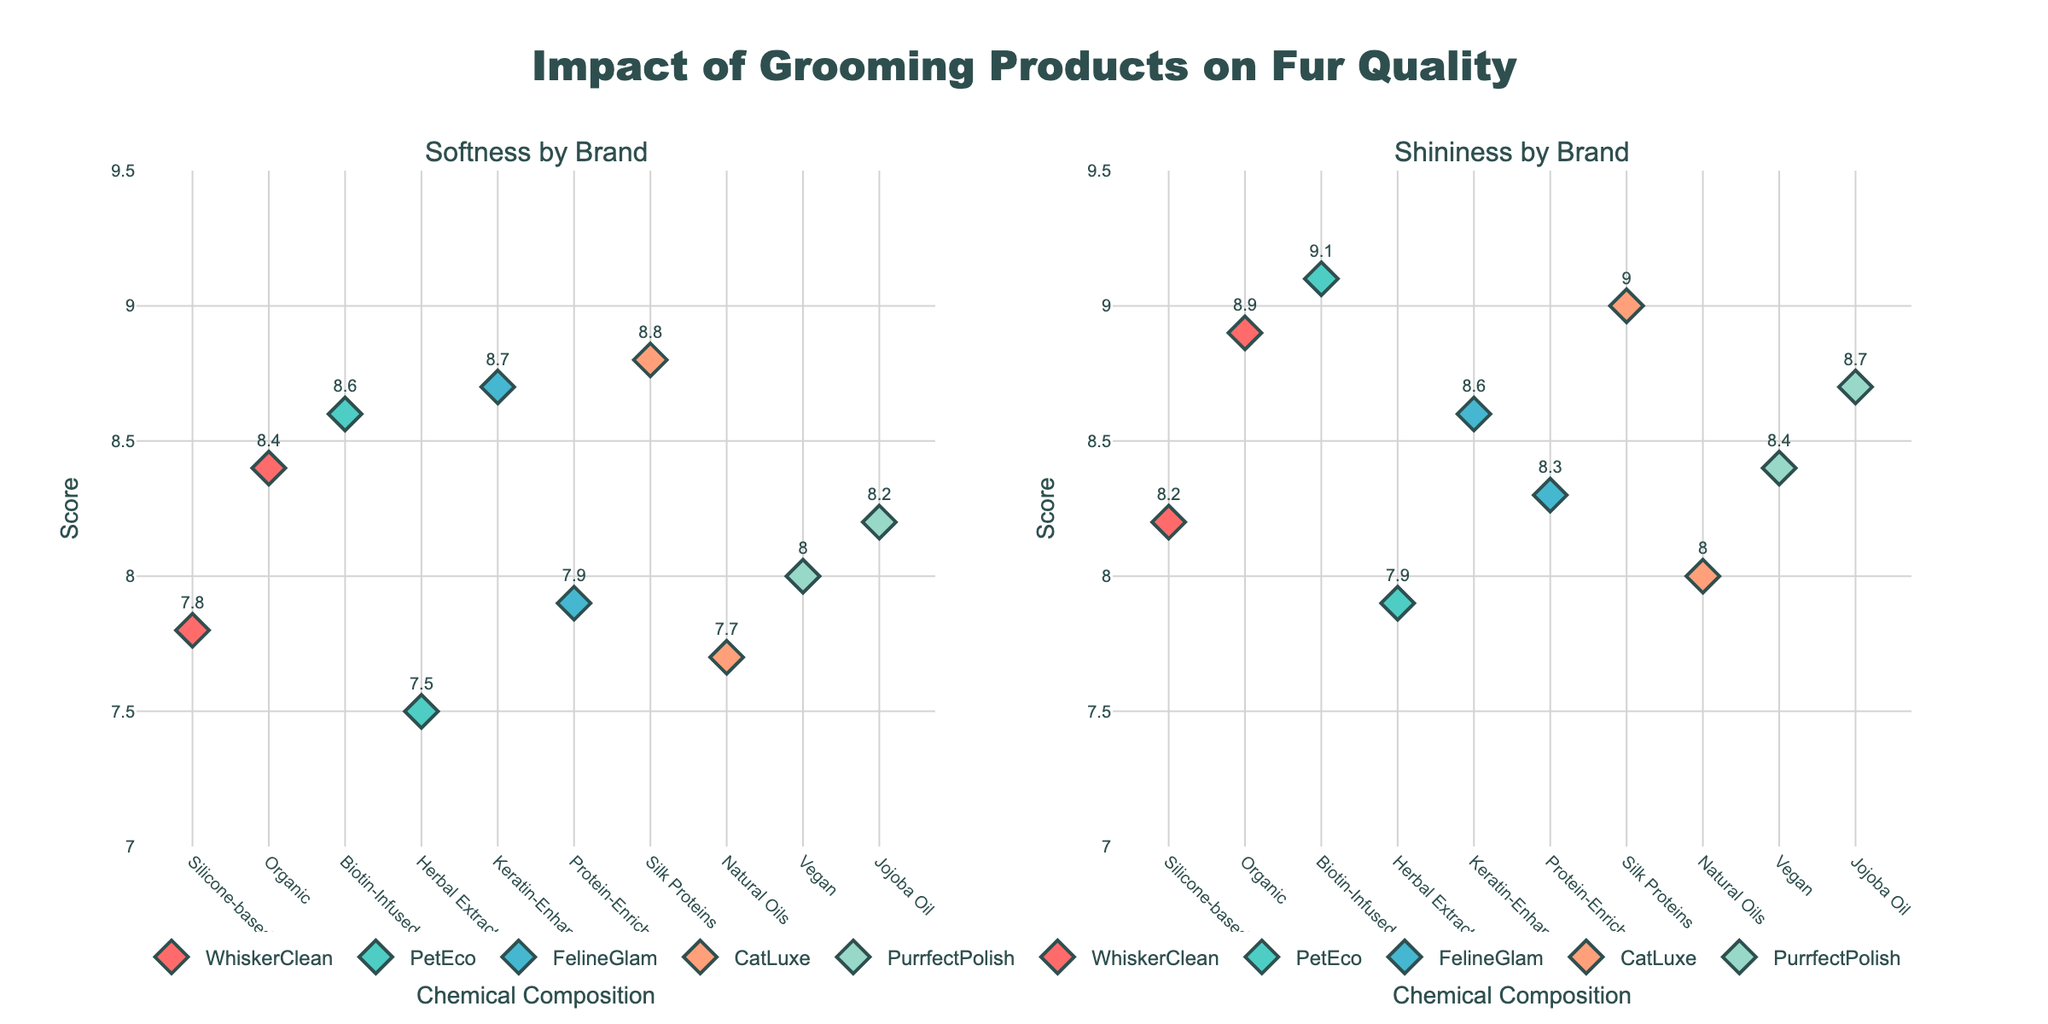What's the title of the plot? The title of the plot is located at the top center of the figure. It reads "Impact of Grooming Products on Fur Quality".
Answer: Impact of Grooming Products on Fur Quality Which brand has the highest softness score? The softness score can be determined from the left subplot titled "Softness by Brand". Identify the highest y-coordinate value, which corresponds to the brand.
Answer: CatLuxe How do the shininess scores compare between WhiskerClean's silicone-based and organic products? Shininess scores for WhiskerClean's products can be observed in the right subplot titled "Shininess by Brand". The silicone-based product is rated at 8.2 and the organic product at 8.9.
Answer: Organic is higher How many data points represent WhiskerClean in the plot? Count the number of data points (markers) labeled with "WhiskerClean" in both subplots. Each data point represents a separate entry.
Answer: 2 What's the average softness score of PetEco's products? PetEco has two softness scores: 8.6 and 7.5. Calculate the average: (8.6 + 7.5)/2 = 8.05.
Answer: 8.05 Which brand shows the highest variance in softness scores? Evaluate the spread between the highest and lowest softness scores for each brand. Identify the brand with the greatest difference.
Answer: WhiskerClean Are there any brands whose shininess scores are all greater than 8.0? Check the right subplot for markers with shininess scores above 8.0 for each brand and confirm if all scores for a brand are above this threshold.
Answer: PetEco, FelineGlam, PurrfectPolish What is the shininess score of CatLuxe's natural oils product? Locate CatLuxe's data points in the shininess subplot and read the shininess score for the 'Natural Oils' chemical composition.
Answer: 8.0 Which chemical compositions result in the softest fur according to the figure? Identify the chemical compositions from the left subplot that have the highest softness scores. These would correspond to the highest y-coordinates on the softness plot.
Answer: Silk Proteins Compare the overall diversity in shininess for PurrfectPolish vs. FelineGlam. Evaluate the range of shininess scores for both brands by comparing the different values shown in the right subplot.
Answer: FelineGlam has more diversity 